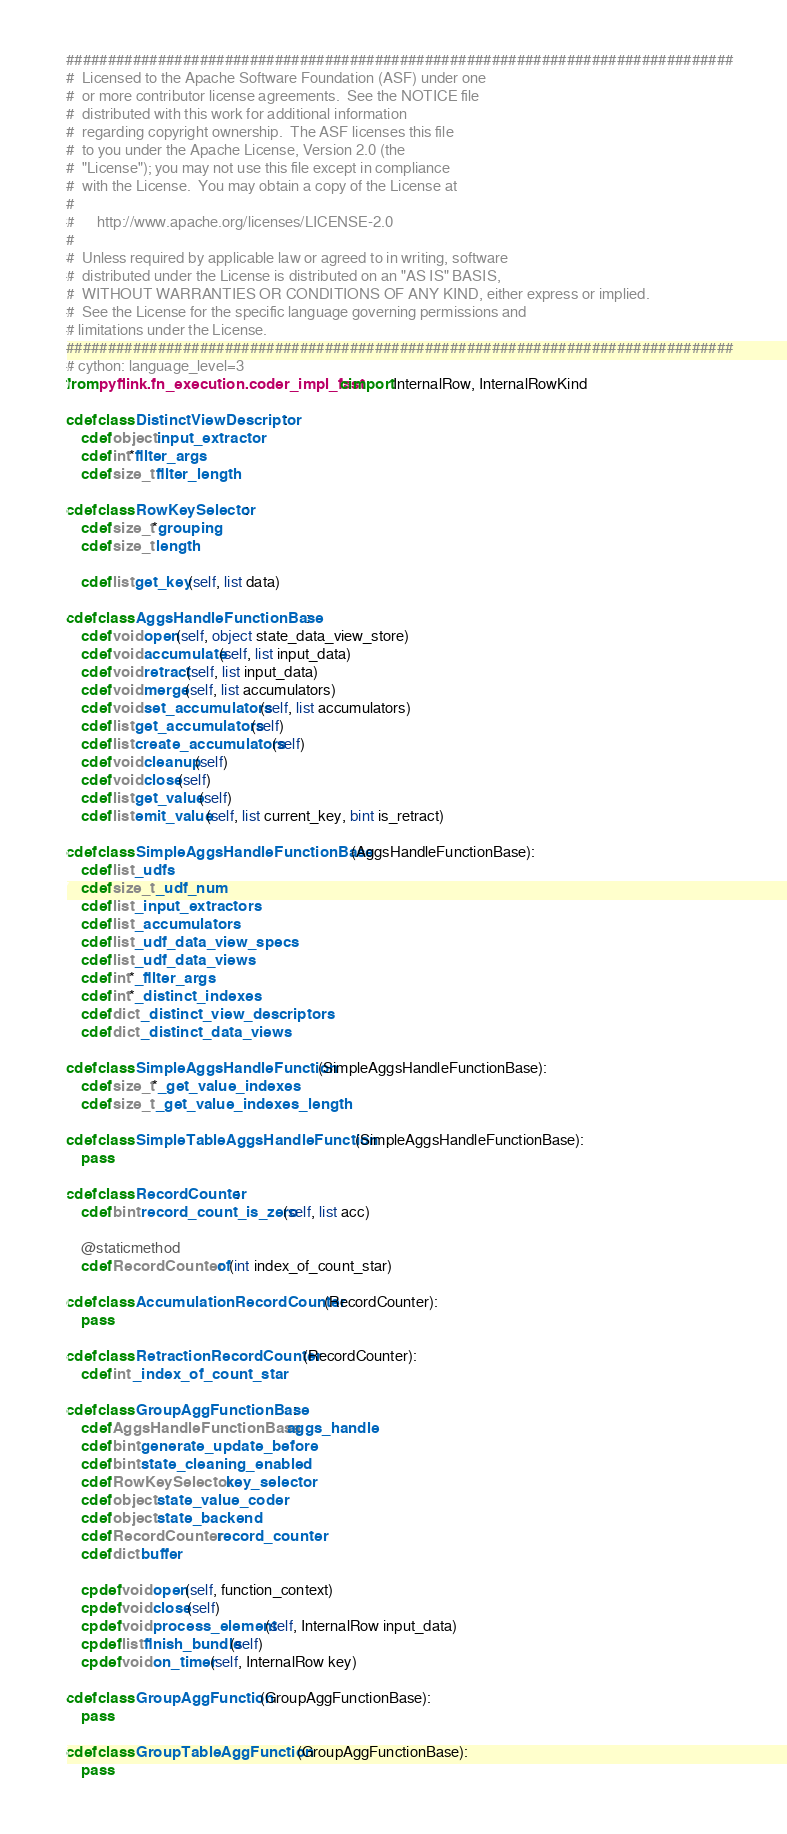<code> <loc_0><loc_0><loc_500><loc_500><_Cython_>################################################################################
#  Licensed to the Apache Software Foundation (ASF) under one
#  or more contributor license agreements.  See the NOTICE file
#  distributed with this work for additional information
#  regarding copyright ownership.  The ASF licenses this file
#  to you under the Apache License, Version 2.0 (the
#  "License"); you may not use this file except in compliance
#  with the License.  You may obtain a copy of the License at
#
#      http://www.apache.org/licenses/LICENSE-2.0
#
#  Unless required by applicable law or agreed to in writing, software
#  distributed under the License is distributed on an "AS IS" BASIS,
#  WITHOUT WARRANTIES OR CONDITIONS OF ANY KIND, either express or implied.
#  See the License for the specific language governing permissions and
# limitations under the License.
################################################################################
# cython: language_level=3
from pyflink.fn_execution.coder_impl_fast cimport InternalRow, InternalRowKind

cdef class DistinctViewDescriptor:
    cdef object input_extractor
    cdef int*filter_args
    cdef size_t filter_length

cdef class RowKeySelector:
    cdef size_t*grouping
    cdef size_t length

    cdef list get_key(self, list data)

cdef class AggsHandleFunctionBase:
    cdef void open(self, object state_data_view_store)
    cdef void accumulate(self, list input_data)
    cdef void retract(self, list input_data)
    cdef void merge(self, list accumulators)
    cdef void set_accumulators(self, list accumulators)
    cdef list get_accumulators(self)
    cdef list create_accumulators(self)
    cdef void cleanup(self)
    cdef void close(self)
    cdef list get_value(self)
    cdef list emit_value(self, list current_key, bint is_retract)

cdef class SimpleAggsHandleFunctionBase(AggsHandleFunctionBase):
    cdef list _udfs
    cdef size_t _udf_num
    cdef list _input_extractors
    cdef list _accumulators
    cdef list _udf_data_view_specs
    cdef list _udf_data_views
    cdef int*_filter_args
    cdef int*_distinct_indexes
    cdef dict _distinct_view_descriptors
    cdef dict _distinct_data_views

cdef class SimpleAggsHandleFunction(SimpleAggsHandleFunctionBase):
    cdef size_t*_get_value_indexes
    cdef size_t _get_value_indexes_length

cdef class SimpleTableAggsHandleFunction(SimpleAggsHandleFunctionBase):
    pass

cdef class RecordCounter:
    cdef bint record_count_is_zero(self, list acc)

    @staticmethod
    cdef RecordCounter of(int index_of_count_star)

cdef class AccumulationRecordCounter(RecordCounter):
    pass

cdef class RetractionRecordCounter(RecordCounter):
    cdef int _index_of_count_star

cdef class GroupAggFunctionBase:
    cdef AggsHandleFunctionBase aggs_handle
    cdef bint generate_update_before
    cdef bint state_cleaning_enabled
    cdef RowKeySelector key_selector
    cdef object state_value_coder
    cdef object state_backend
    cdef RecordCounter record_counter
    cdef dict buffer

    cpdef void open(self, function_context)
    cpdef void close(self)
    cpdef void process_element(self, InternalRow input_data)
    cpdef list finish_bundle(self)
    cpdef void on_timer(self, InternalRow key)

cdef class GroupAggFunction(GroupAggFunctionBase):
    pass

cdef class GroupTableAggFunction(GroupAggFunctionBase):
    pass
</code> 